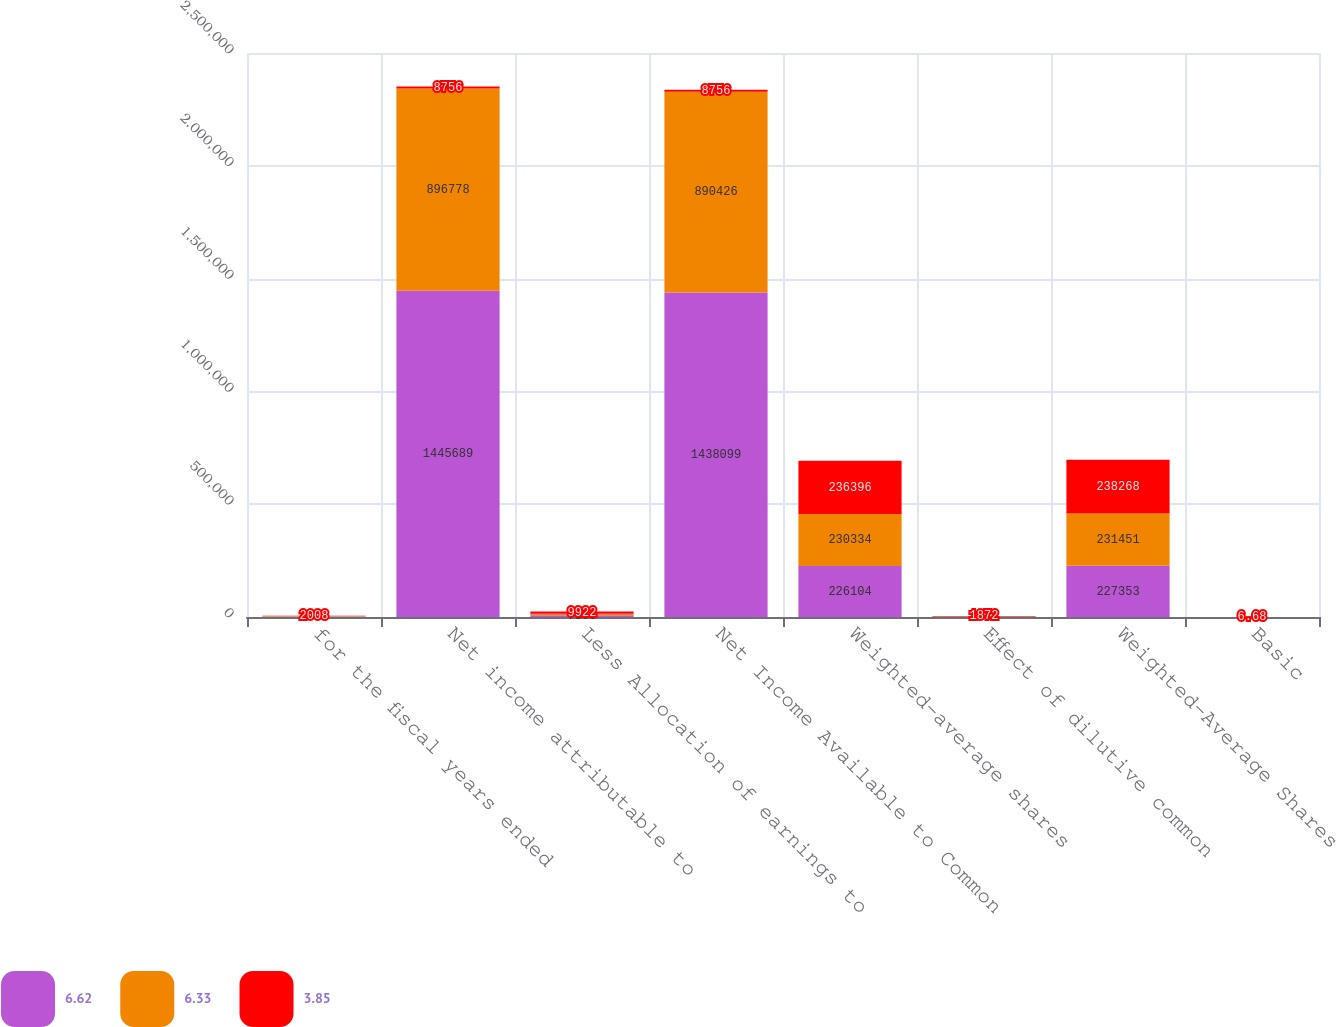<chart> <loc_0><loc_0><loc_500><loc_500><stacked_bar_chart><ecel><fcel>for the fiscal years ended<fcel>Net income attributable to<fcel>Less Allocation of earnings to<fcel>Net Income Available to Common<fcel>Weighted-average shares<fcel>Effect of dilutive common<fcel>Weighted-Average Shares<fcel>Basic<nl><fcel>6.62<fcel>2010<fcel>1.44569e+06<fcel>7590<fcel>1.4381e+06<fcel>226104<fcel>1249<fcel>227353<fcel>6.36<nl><fcel>6.33<fcel>2009<fcel>896778<fcel>6352<fcel>890426<fcel>230334<fcel>1117<fcel>231451<fcel>3.87<nl><fcel>3.85<fcel>2008<fcel>8756<fcel>9922<fcel>8756<fcel>236396<fcel>1872<fcel>238268<fcel>6.68<nl></chart> 